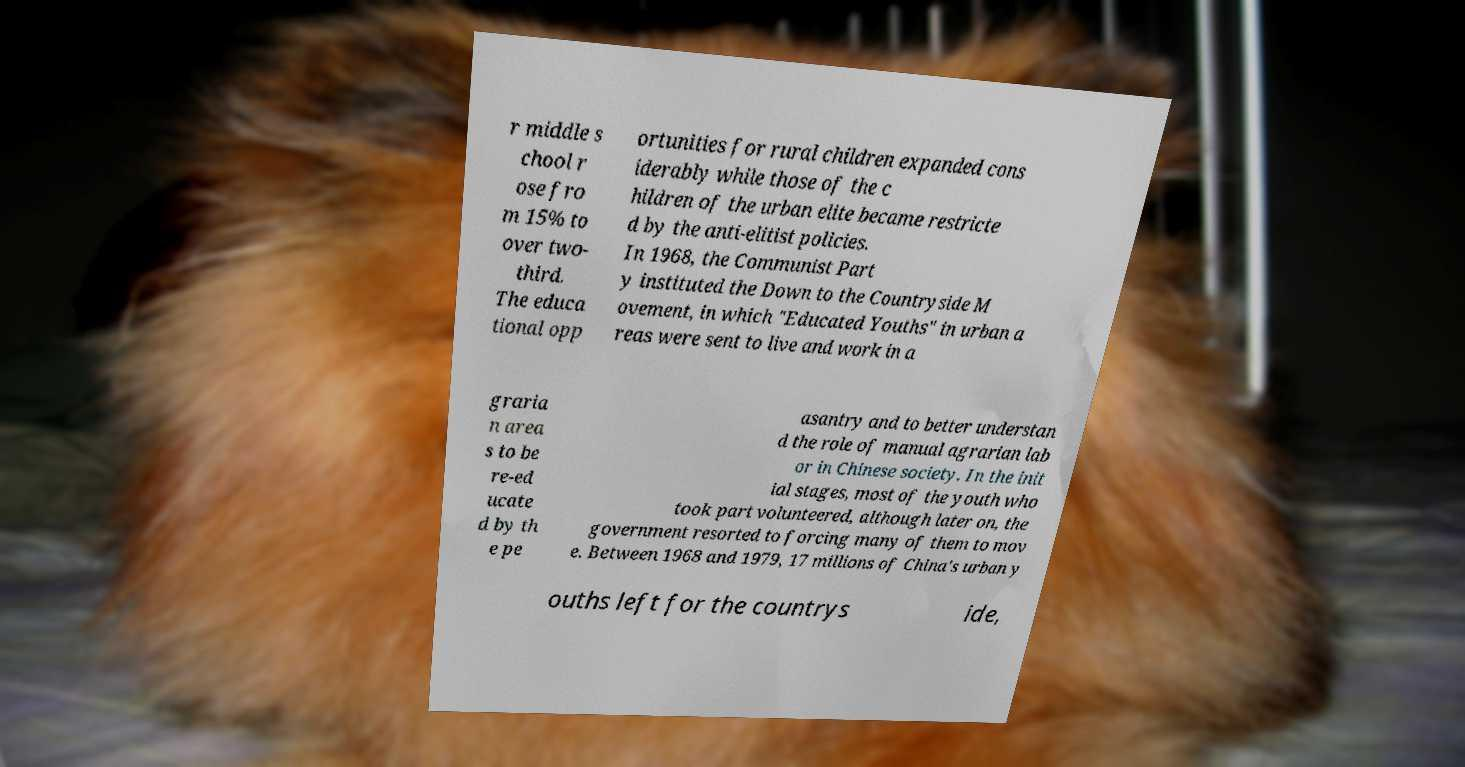Can you read and provide the text displayed in the image?This photo seems to have some interesting text. Can you extract and type it out for me? r middle s chool r ose fro m 15% to over two- third. The educa tional opp ortunities for rural children expanded cons iderably while those of the c hildren of the urban elite became restricte d by the anti-elitist policies. In 1968, the Communist Part y instituted the Down to the Countryside M ovement, in which "Educated Youths" in urban a reas were sent to live and work in a graria n area s to be re-ed ucate d by th e pe asantry and to better understan d the role of manual agrarian lab or in Chinese society. In the init ial stages, most of the youth who took part volunteered, although later on, the government resorted to forcing many of them to mov e. Between 1968 and 1979, 17 millions of China's urban y ouths left for the countrys ide, 